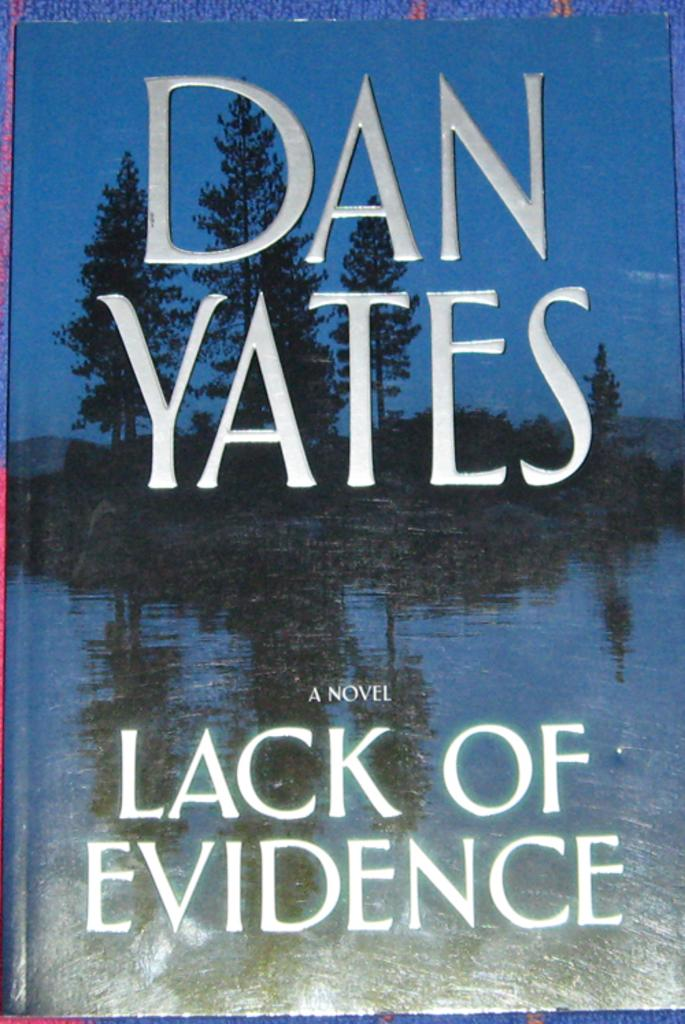<image>
Provide a brief description of the given image. Book cover for "Lack of Evidence" showing a creek with trees at night. 